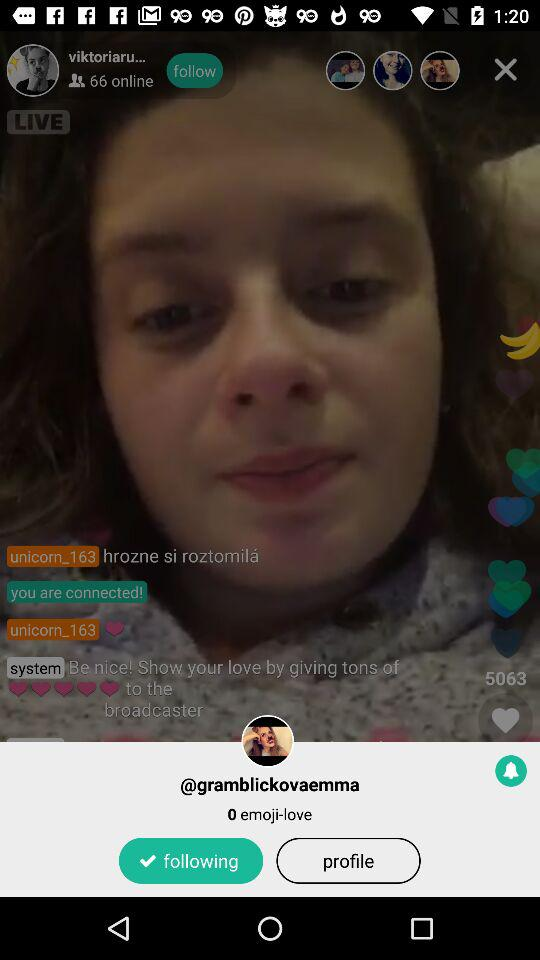How many favourites are shown here? There are 5063 favourites shown. 